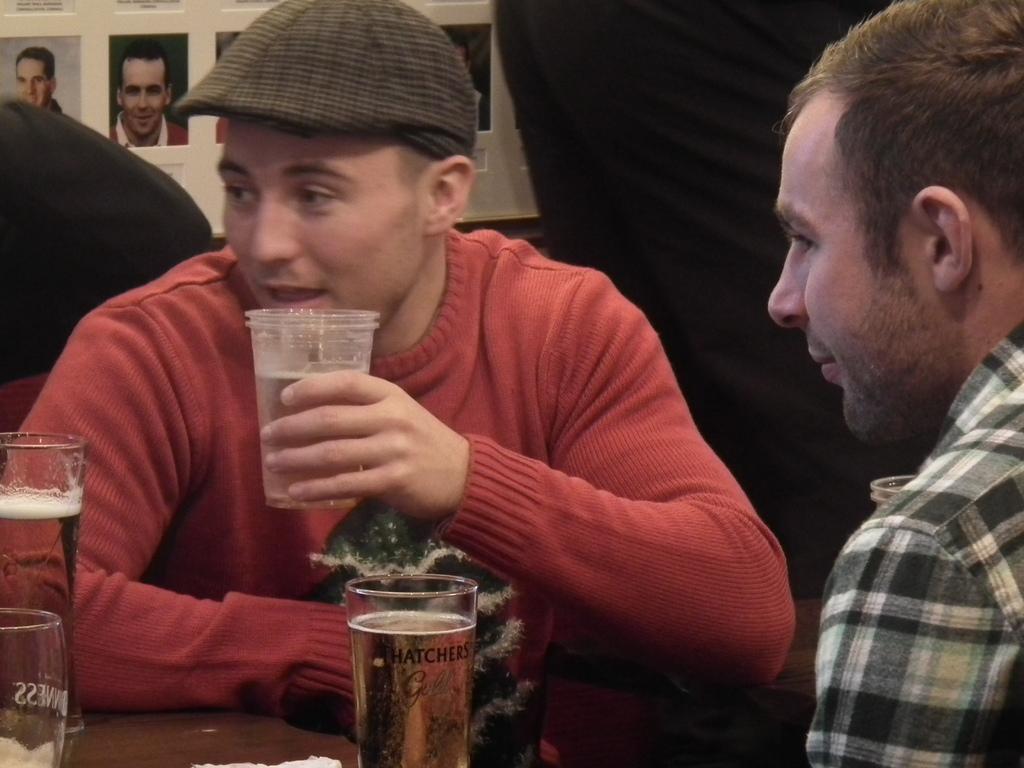How would you summarize this image in a sentence or two? There are two men sitting in front of each other. One off the guy is holding a glass in his hand. And there are two glasses in front of them. In the background we can observe some photographs to the wall. 